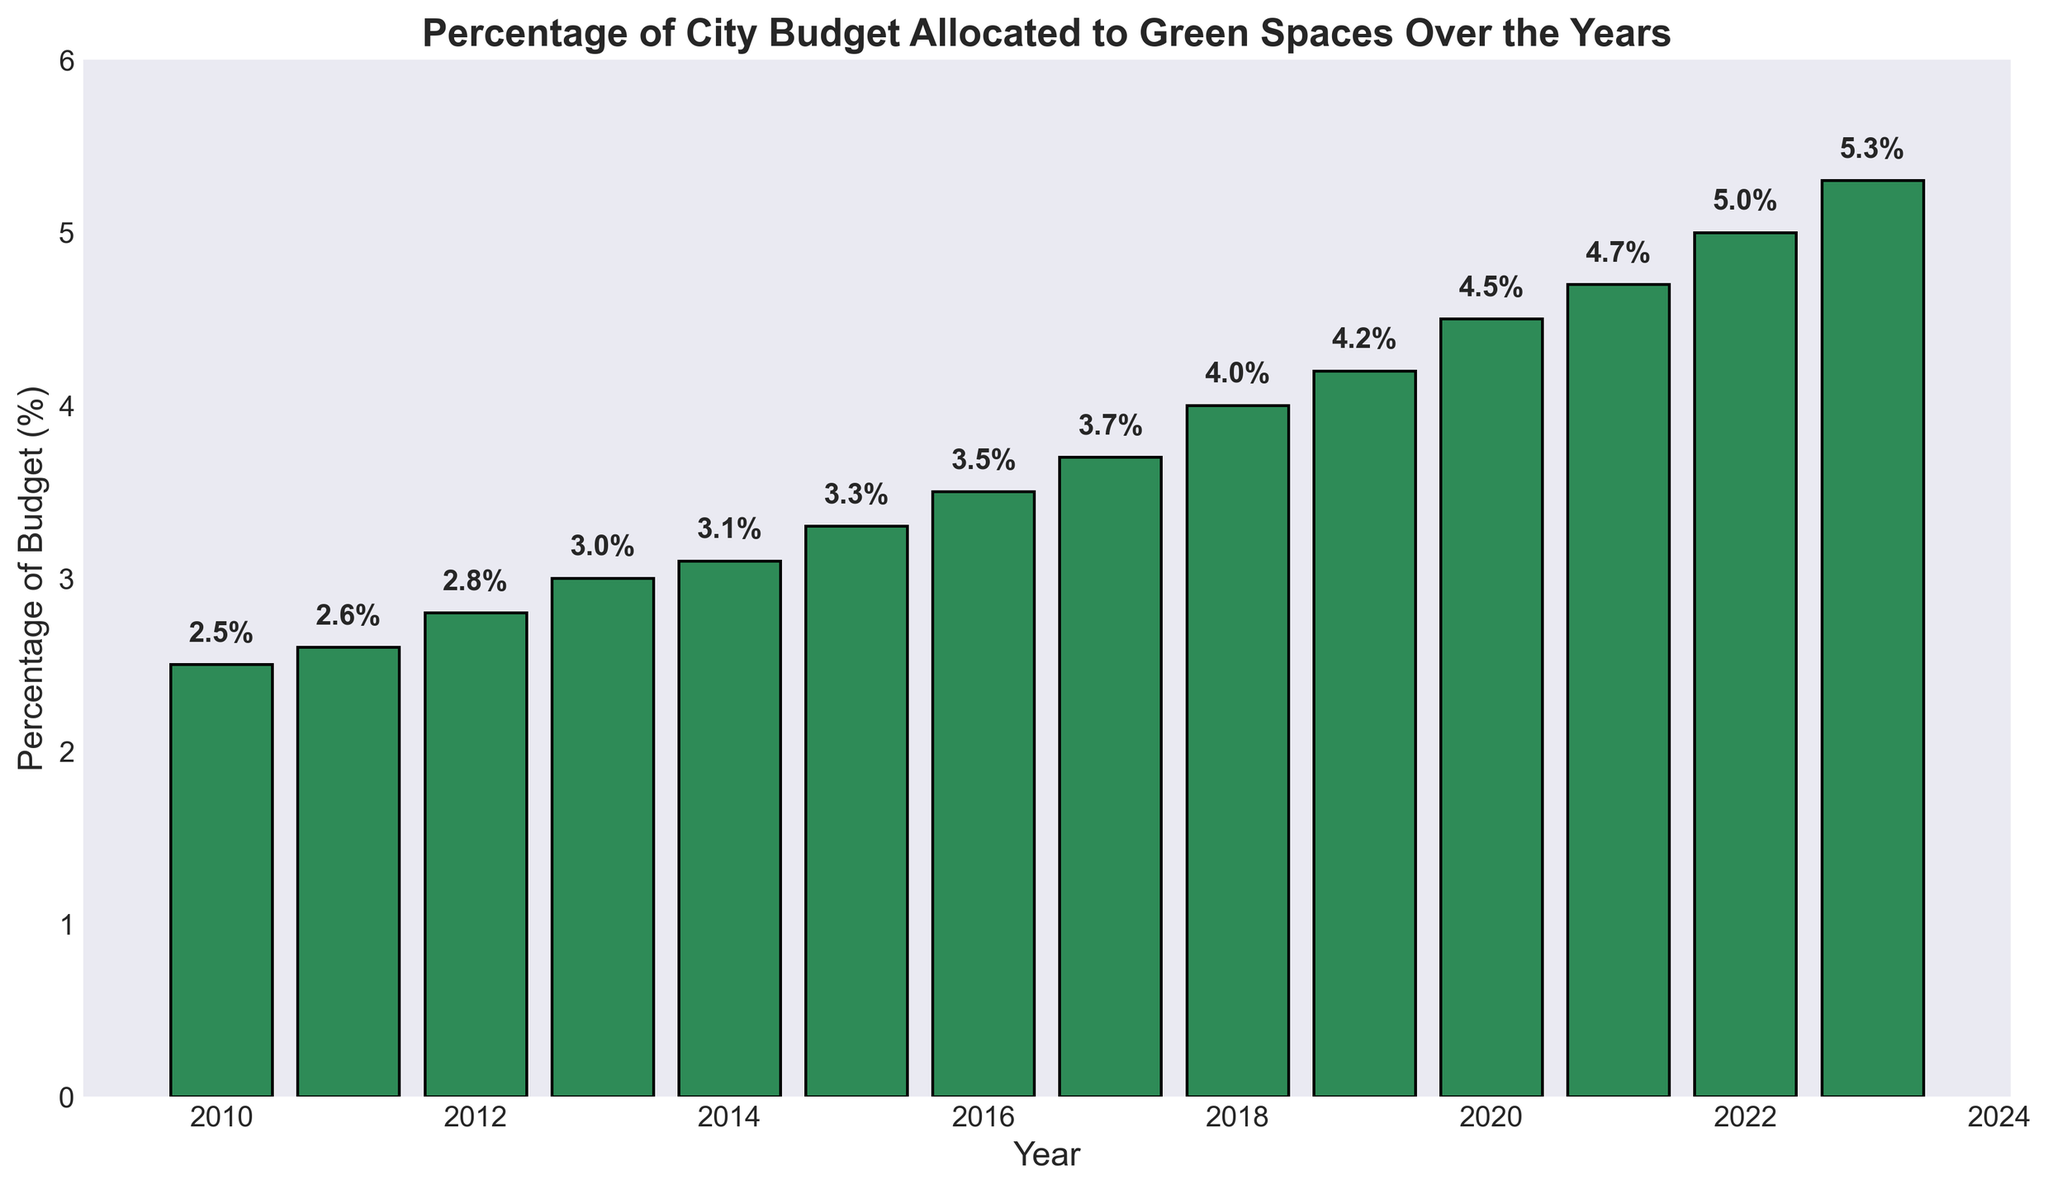What's the highest percentage of the city budget allocated to green spaces in the given years? The highest percentage can be observed by looking for the tallest bar in the chart. The tallest bar represents the year 2023 with a value of 5.3%.
Answer: 5.3% Which year observed the largest increase in the percentage allocated to green spaces compared to the previous year? To find the largest increase, calculate the differences year by year and identify the maximum difference. The largest increase is from 2017 to 2018 (0.3%).
Answer: 2017 to 2018 What is the average percentage of the city budget allocated to green spaces from 2010 to 2023? Sum the percentages from 2010 to 2023 and divide by the number of years (14). The total is 53.8; thus, the average is 53.8/14 = 3.84%.
Answer: 3.84% In which year did the percentage of the city budget allocated to green spaces first exceed 4%? Look for the first bar that reaches above the 4% mark, which is in the year 2018.
Answer: 2018 How much did the percentage allocated to green spaces increase from 2010 to 2023? Subtract the value in 2010 from the value in 2023. The increase is 5.3% - 2.5% = 2.8%.
Answer: 2.8% Which two consecutive years showed the smallest increase in the percentage allocated to green spaces? Compare the year-to-year differences and identify the smallest one. The smallest increase is from 2010 to 2011 (0.1%).
Answer: 2010 to 2011 Are there any years where the percentage of the city budget allocated to green spaces did not increase? Check each year to see if there's any year where the percentage stayed the same or decreased. All years show an increase.
Answer: No What is the total increase in the percentage allocated to green spaces from 2015 to 2023? Subtract the value in 2015 from the value in 2023. The increase is 5.3% - 3.3% = 2.0%.
Answer: 2.0% What is the median percentage of the city budget allocated to green spaces? List the percentages in ascending order and find the middle value (since there are 14 years, the median is the average of the 7th and 8th values, 3.3% and 3.5%). The median is (3.3 + 3.5) / 2 = 3.4%.
Answer: 3.4% 